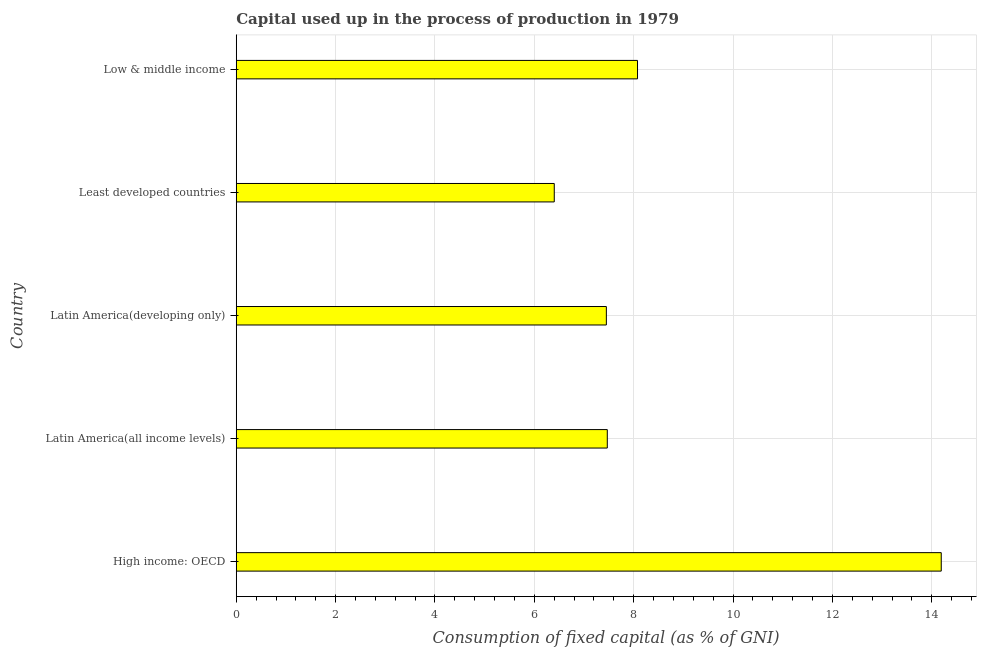Does the graph contain any zero values?
Provide a short and direct response. No. Does the graph contain grids?
Keep it short and to the point. Yes. What is the title of the graph?
Offer a very short reply. Capital used up in the process of production in 1979. What is the label or title of the X-axis?
Provide a succinct answer. Consumption of fixed capital (as % of GNI). What is the consumption of fixed capital in Low & middle income?
Ensure brevity in your answer.  8.08. Across all countries, what is the maximum consumption of fixed capital?
Provide a succinct answer. 14.19. Across all countries, what is the minimum consumption of fixed capital?
Your answer should be compact. 6.4. In which country was the consumption of fixed capital maximum?
Make the answer very short. High income: OECD. In which country was the consumption of fixed capital minimum?
Provide a succinct answer. Least developed countries. What is the sum of the consumption of fixed capital?
Provide a succinct answer. 43.59. What is the difference between the consumption of fixed capital in Latin America(all income levels) and Latin America(developing only)?
Give a very brief answer. 0.02. What is the average consumption of fixed capital per country?
Make the answer very short. 8.72. What is the median consumption of fixed capital?
Give a very brief answer. 7.47. What is the ratio of the consumption of fixed capital in High income: OECD to that in Low & middle income?
Offer a very short reply. 1.76. Is the consumption of fixed capital in Latin America(developing only) less than that in Low & middle income?
Provide a short and direct response. Yes. Is the difference between the consumption of fixed capital in Latin America(developing only) and Low & middle income greater than the difference between any two countries?
Your answer should be compact. No. What is the difference between the highest and the second highest consumption of fixed capital?
Offer a terse response. 6.11. What is the difference between the highest and the lowest consumption of fixed capital?
Ensure brevity in your answer.  7.79. In how many countries, is the consumption of fixed capital greater than the average consumption of fixed capital taken over all countries?
Provide a succinct answer. 1. How many bars are there?
Give a very brief answer. 5. Are all the bars in the graph horizontal?
Offer a very short reply. Yes. What is the difference between two consecutive major ticks on the X-axis?
Offer a very short reply. 2. What is the Consumption of fixed capital (as % of GNI) in High income: OECD?
Give a very brief answer. 14.19. What is the Consumption of fixed capital (as % of GNI) of Latin America(all income levels)?
Your answer should be very brief. 7.47. What is the Consumption of fixed capital (as % of GNI) of Latin America(developing only)?
Give a very brief answer. 7.45. What is the Consumption of fixed capital (as % of GNI) of Least developed countries?
Offer a terse response. 6.4. What is the Consumption of fixed capital (as % of GNI) in Low & middle income?
Make the answer very short. 8.08. What is the difference between the Consumption of fixed capital (as % of GNI) in High income: OECD and Latin America(all income levels)?
Make the answer very short. 6.72. What is the difference between the Consumption of fixed capital (as % of GNI) in High income: OECD and Latin America(developing only)?
Your answer should be very brief. 6.74. What is the difference between the Consumption of fixed capital (as % of GNI) in High income: OECD and Least developed countries?
Your answer should be very brief. 7.79. What is the difference between the Consumption of fixed capital (as % of GNI) in High income: OECD and Low & middle income?
Provide a short and direct response. 6.11. What is the difference between the Consumption of fixed capital (as % of GNI) in Latin America(all income levels) and Latin America(developing only)?
Make the answer very short. 0.02. What is the difference between the Consumption of fixed capital (as % of GNI) in Latin America(all income levels) and Least developed countries?
Provide a succinct answer. 1.07. What is the difference between the Consumption of fixed capital (as % of GNI) in Latin America(all income levels) and Low & middle income?
Offer a very short reply. -0.61. What is the difference between the Consumption of fixed capital (as % of GNI) in Latin America(developing only) and Least developed countries?
Your answer should be very brief. 1.05. What is the difference between the Consumption of fixed capital (as % of GNI) in Latin America(developing only) and Low & middle income?
Offer a very short reply. -0.63. What is the difference between the Consumption of fixed capital (as % of GNI) in Least developed countries and Low & middle income?
Your response must be concise. -1.68. What is the ratio of the Consumption of fixed capital (as % of GNI) in High income: OECD to that in Latin America(all income levels)?
Your answer should be compact. 1.9. What is the ratio of the Consumption of fixed capital (as % of GNI) in High income: OECD to that in Latin America(developing only)?
Your answer should be very brief. 1.91. What is the ratio of the Consumption of fixed capital (as % of GNI) in High income: OECD to that in Least developed countries?
Provide a succinct answer. 2.22. What is the ratio of the Consumption of fixed capital (as % of GNI) in High income: OECD to that in Low & middle income?
Provide a succinct answer. 1.76. What is the ratio of the Consumption of fixed capital (as % of GNI) in Latin America(all income levels) to that in Least developed countries?
Keep it short and to the point. 1.17. What is the ratio of the Consumption of fixed capital (as % of GNI) in Latin America(all income levels) to that in Low & middle income?
Make the answer very short. 0.93. What is the ratio of the Consumption of fixed capital (as % of GNI) in Latin America(developing only) to that in Least developed countries?
Your answer should be very brief. 1.16. What is the ratio of the Consumption of fixed capital (as % of GNI) in Latin America(developing only) to that in Low & middle income?
Give a very brief answer. 0.92. What is the ratio of the Consumption of fixed capital (as % of GNI) in Least developed countries to that in Low & middle income?
Offer a terse response. 0.79. 